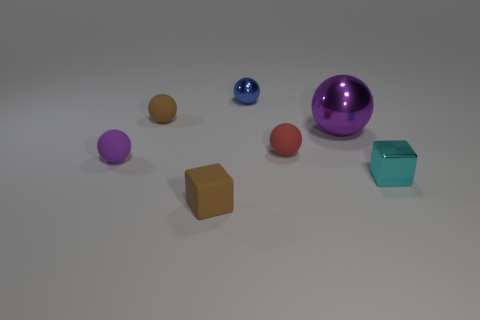There is a tiny cyan metallic thing; is it the same shape as the tiny brown matte object in front of the red matte object?
Ensure brevity in your answer.  Yes. Is the size of the brown object that is behind the cyan block the same as the small cyan metallic object?
Your answer should be very brief. Yes. There is another shiny thing that is the same size as the cyan metal object; what is its shape?
Offer a terse response. Sphere. Is the shape of the red thing the same as the blue shiny thing?
Provide a succinct answer. Yes. How many other purple shiny objects are the same shape as the tiny purple thing?
Your response must be concise. 1. There is a tiny brown rubber ball; how many small cyan metal objects are left of it?
Your answer should be compact. 0. There is a small rubber ball that is in front of the tiny red thing; is it the same color as the big metallic thing?
Provide a succinct answer. Yes. How many cubes are the same size as the blue thing?
Offer a terse response. 2. The small cyan object that is the same material as the large thing is what shape?
Your response must be concise. Cube. Are there any objects of the same color as the small rubber block?
Provide a succinct answer. Yes. 